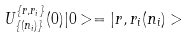<formula> <loc_0><loc_0><loc_500><loc_500>U _ { \{ ( n _ { i } ) \} } ^ { \{ r , r _ { i } \} } ( 0 ) | 0 > = | r , r _ { i } ( n _ { i } ) ></formula> 